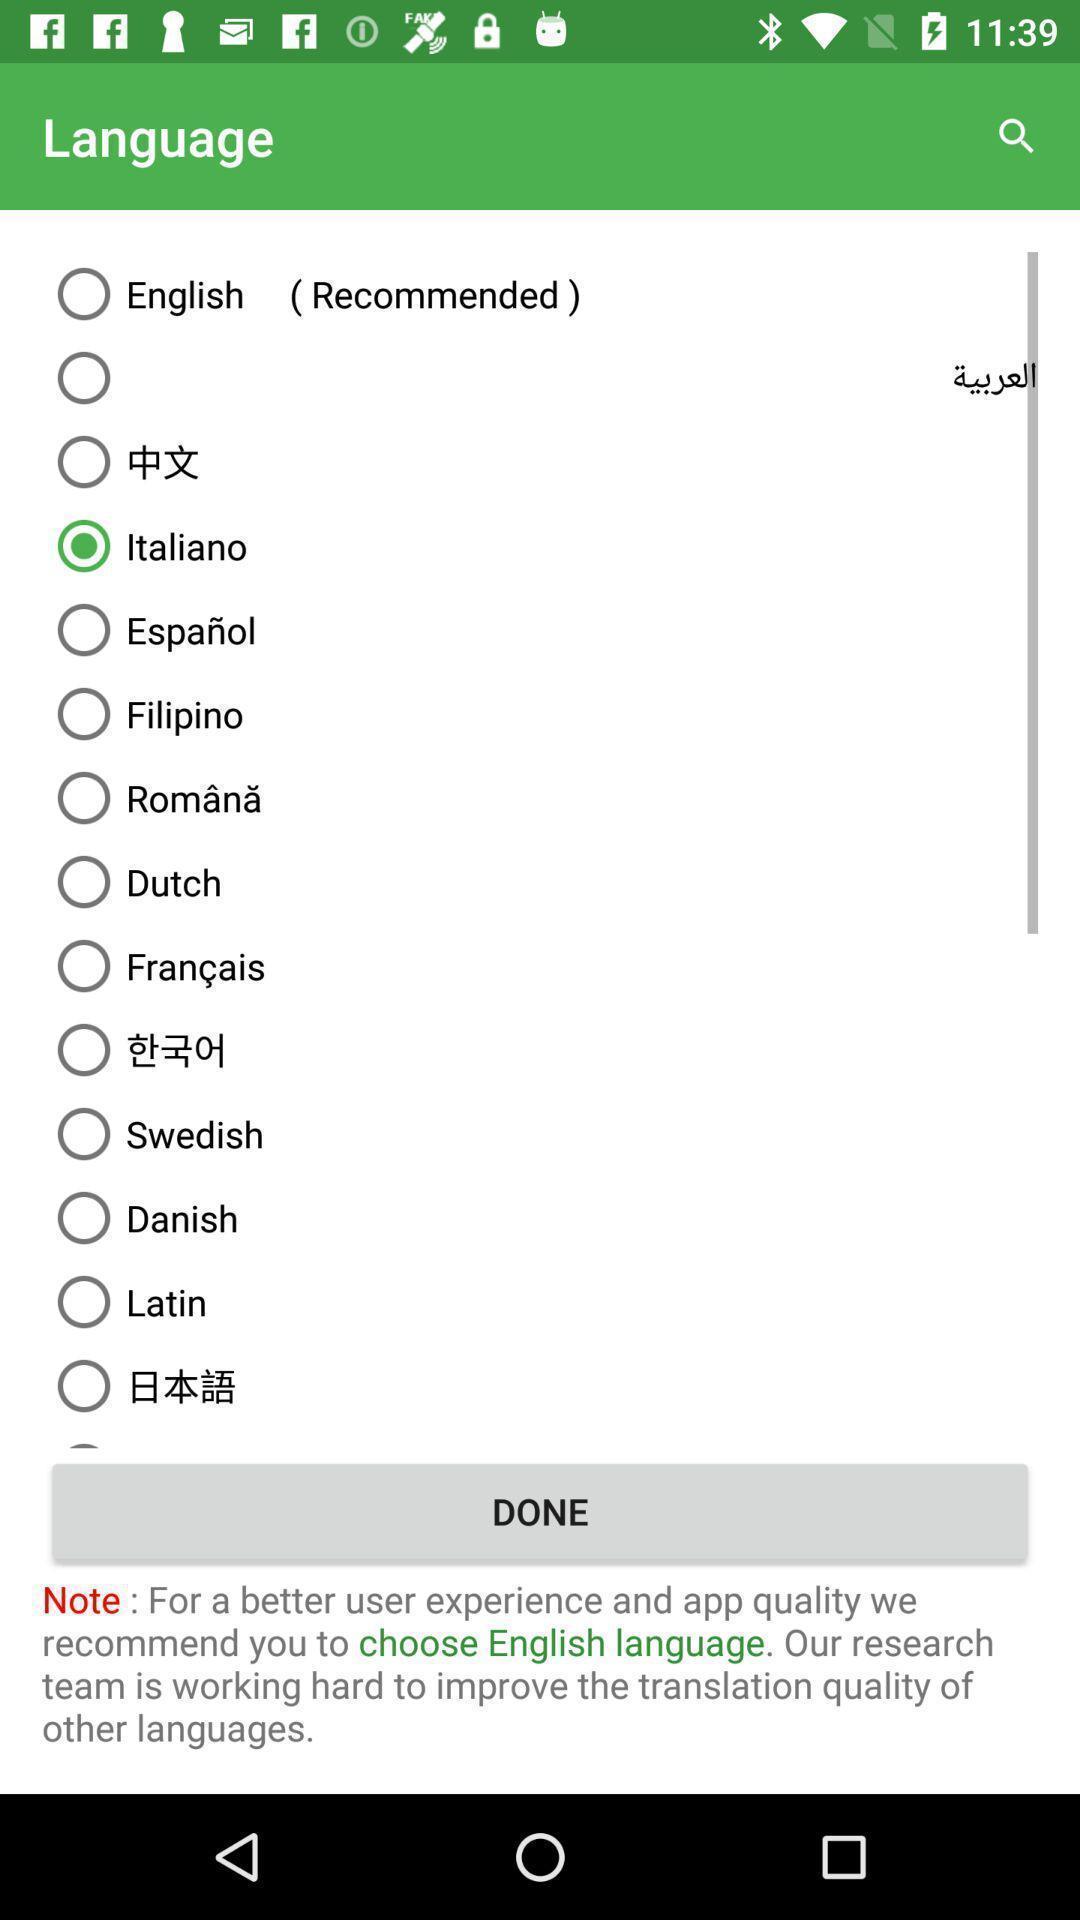Explain the elements present in this screenshot. Page showing different languages to select on an app. 